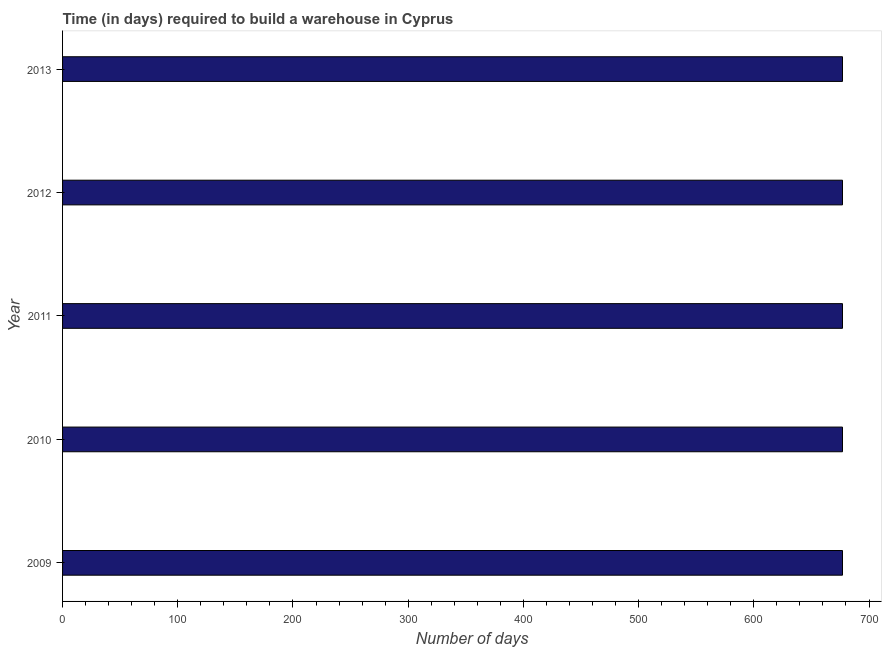What is the title of the graph?
Offer a very short reply. Time (in days) required to build a warehouse in Cyprus. What is the label or title of the X-axis?
Make the answer very short. Number of days. What is the label or title of the Y-axis?
Provide a short and direct response. Year. What is the time required to build a warehouse in 2010?
Your answer should be compact. 677. Across all years, what is the maximum time required to build a warehouse?
Keep it short and to the point. 677. Across all years, what is the minimum time required to build a warehouse?
Your answer should be very brief. 677. In which year was the time required to build a warehouse maximum?
Keep it short and to the point. 2009. What is the sum of the time required to build a warehouse?
Offer a very short reply. 3385. What is the difference between the time required to build a warehouse in 2010 and 2013?
Provide a short and direct response. 0. What is the average time required to build a warehouse per year?
Keep it short and to the point. 677. What is the median time required to build a warehouse?
Offer a terse response. 677. In how many years, is the time required to build a warehouse greater than 520 days?
Make the answer very short. 5. What is the ratio of the time required to build a warehouse in 2011 to that in 2012?
Your response must be concise. 1. Is the time required to build a warehouse in 2009 less than that in 2011?
Provide a succinct answer. No. What is the difference between the highest and the second highest time required to build a warehouse?
Give a very brief answer. 0. Is the sum of the time required to build a warehouse in 2011 and 2013 greater than the maximum time required to build a warehouse across all years?
Ensure brevity in your answer.  Yes. What is the difference between the highest and the lowest time required to build a warehouse?
Your response must be concise. 0. In how many years, is the time required to build a warehouse greater than the average time required to build a warehouse taken over all years?
Provide a succinct answer. 0. How many bars are there?
Your response must be concise. 5. How many years are there in the graph?
Your answer should be very brief. 5. What is the difference between two consecutive major ticks on the X-axis?
Ensure brevity in your answer.  100. What is the Number of days of 2009?
Offer a terse response. 677. What is the Number of days in 2010?
Your answer should be compact. 677. What is the Number of days in 2011?
Provide a succinct answer. 677. What is the Number of days in 2012?
Give a very brief answer. 677. What is the Number of days in 2013?
Keep it short and to the point. 677. What is the difference between the Number of days in 2010 and 2011?
Provide a short and direct response. 0. What is the difference between the Number of days in 2010 and 2012?
Make the answer very short. 0. What is the difference between the Number of days in 2010 and 2013?
Your answer should be very brief. 0. What is the difference between the Number of days in 2011 and 2012?
Provide a succinct answer. 0. What is the ratio of the Number of days in 2009 to that in 2012?
Give a very brief answer. 1. What is the ratio of the Number of days in 2009 to that in 2013?
Ensure brevity in your answer.  1. What is the ratio of the Number of days in 2010 to that in 2012?
Give a very brief answer. 1. What is the ratio of the Number of days in 2011 to that in 2012?
Offer a terse response. 1. What is the ratio of the Number of days in 2012 to that in 2013?
Your response must be concise. 1. 